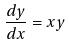<formula> <loc_0><loc_0><loc_500><loc_500>\frac { d y } { d x } = x y</formula> 